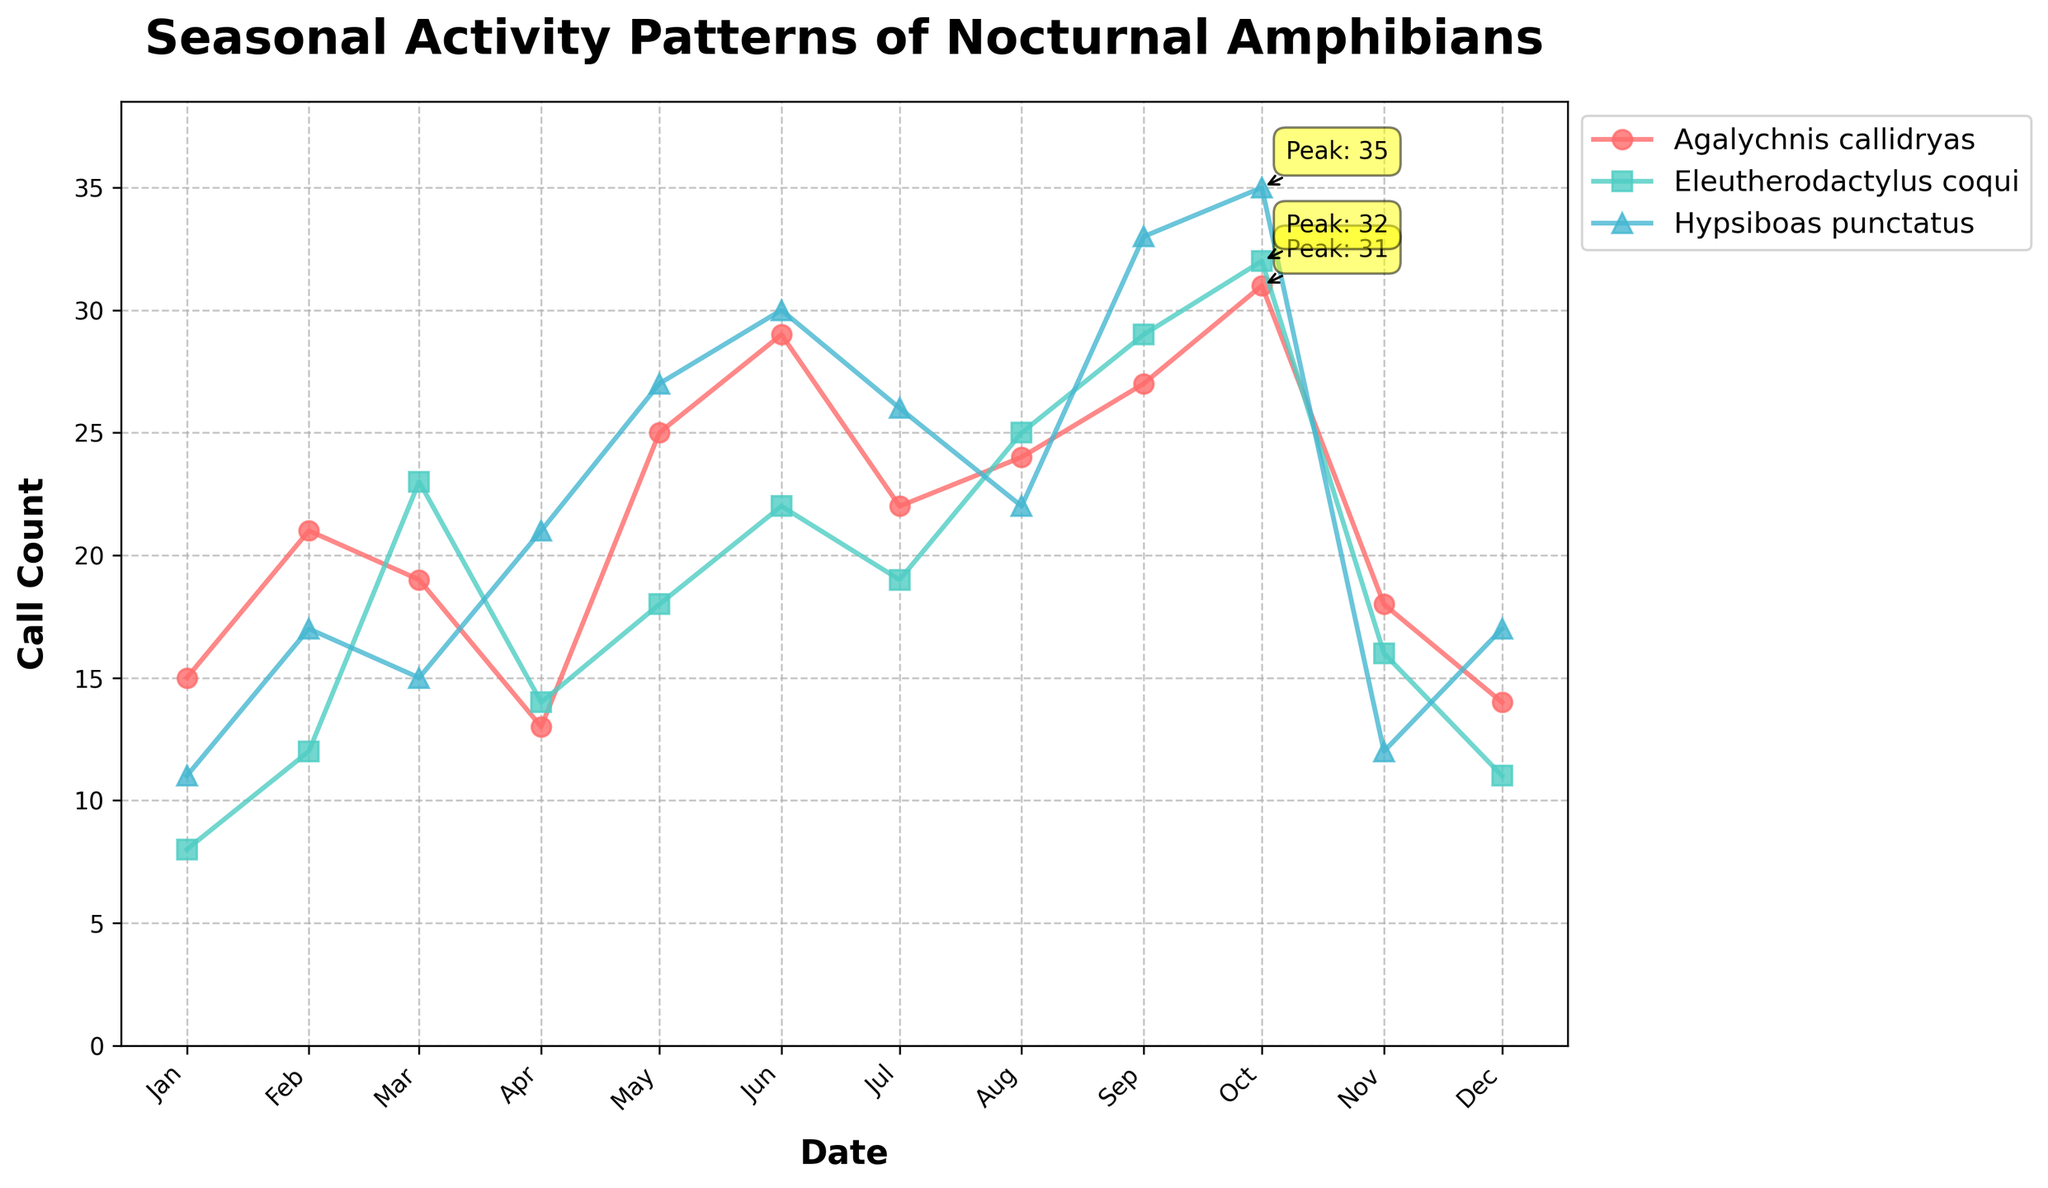What is the title of the time series plot? The title of the plot is usually displayed at the top and summarises the content of the figure.
Answer: Seasonal Activity Patterns of Nocturnal Amphibians Which species has the highest call count on October 1st, 2023? To find the species with the highest call count on October 1st, 2023, check the values on the corresponding date in the plot. Look at the peaks labeled with call counts for that date.
Answer: Hypsiboas punctatus When did Agalychnis callidryas have its peak call count? Identify the point on the plot where the call count for Agalychnis callidryas is highest. We can also look for the annotation labeled "Peak".
Answer: October 2023 Compare the call counts of Eleutherodactylus coqui and Hypsiboas punctatus in May. Which species had a higher call count? Find the data points for both species in May and compare their call counts directly.
Answer: Hypsiboas punctatus What is the lowest call count recorded for Hypsiboas punctatus and in which month? Check the plot for the lowest point in the line representing Hypsiboas punctatus and note the corresponding month.
Answer: November 2023 How do the peak months for Hypsiboas punctatus and Agalychnis callidryas compare? Identify the peak call count month for both species on the plot and compare them. If they are the same, describe that; otherwise, describe which months they are.
Answer: Both peaks are in October 2023 What are the call counts for all three species in June? Find the data points for June, and read the values for Agalychnis callidryas, Eleutherodactylus coqui, and Hypsiboas punctatus.
Answer: Agalychnis callidryas: 29, Eleutherodactylus coqui: 22, Hypsiboas punctatus: 30 During which month did Eleutherodactylus coqui experience the largest increase in call count compared to the previous month? Examine the call count changes month-by-month for Eleutherodactylus coqui and calculate the differences to find the largest increase.
Answer: October Between which two consecutive months did Agalychnis callidryas show the greatest increase in call counts? Examine the call count for Agalychnis callidryas each month and find the greatest difference between two consecutive months.
Answer: April to May What is the general trend of call counts for Agalychnis callidryas throughout the year? Observe the line for Agalychnis callidryas across the entire x-axis and summarize whether it is generally rising, falling, or fluctuating.
Answer: Generally rising until October, then falling 